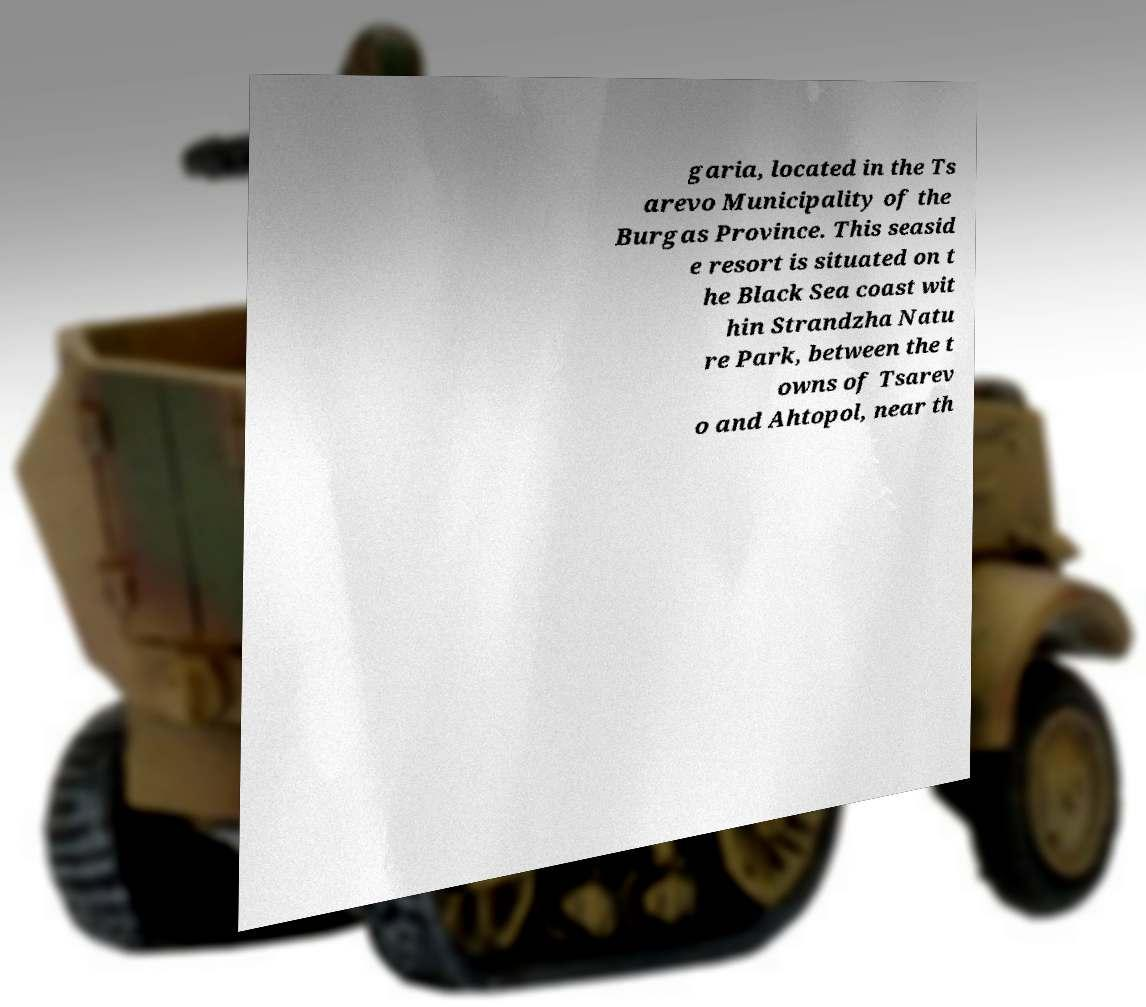What messages or text are displayed in this image? I need them in a readable, typed format. garia, located in the Ts arevo Municipality of the Burgas Province. This seasid e resort is situated on t he Black Sea coast wit hin Strandzha Natu re Park, between the t owns of Tsarev o and Ahtopol, near th 